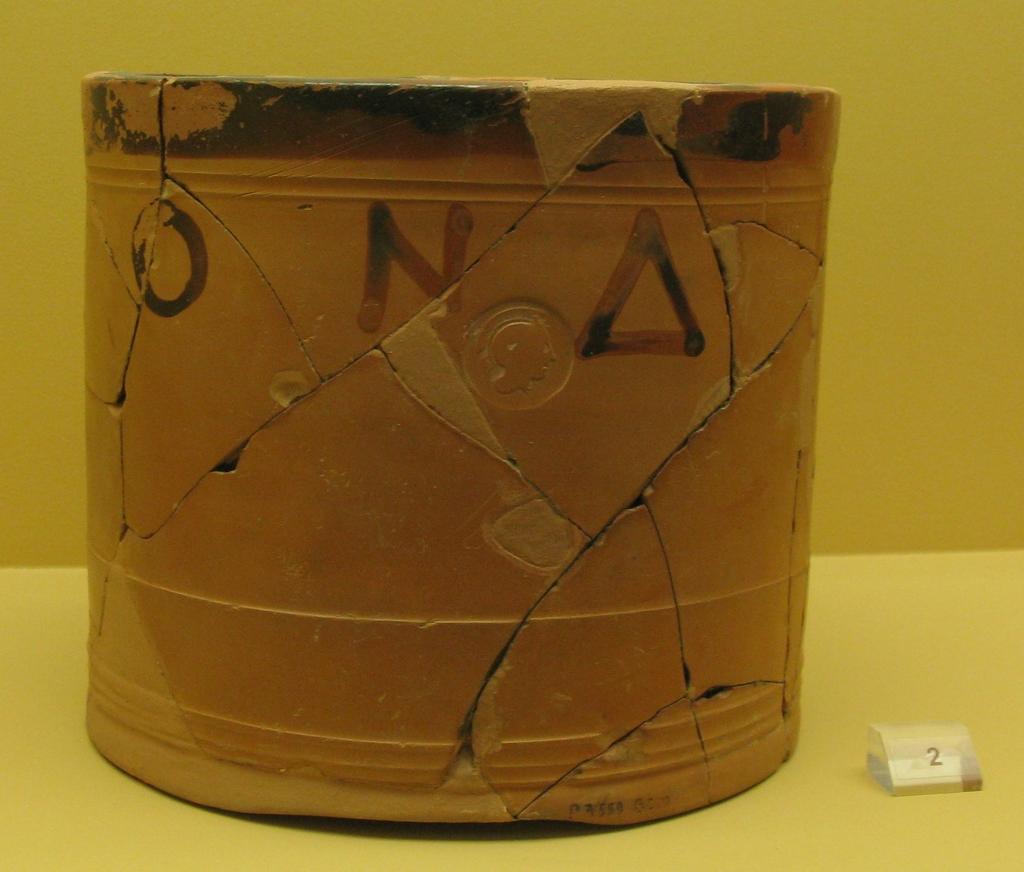What is the number beside the bucket?
Your answer should be compact. 2. What letters are on the bucket?
Offer a very short reply. Ona. 